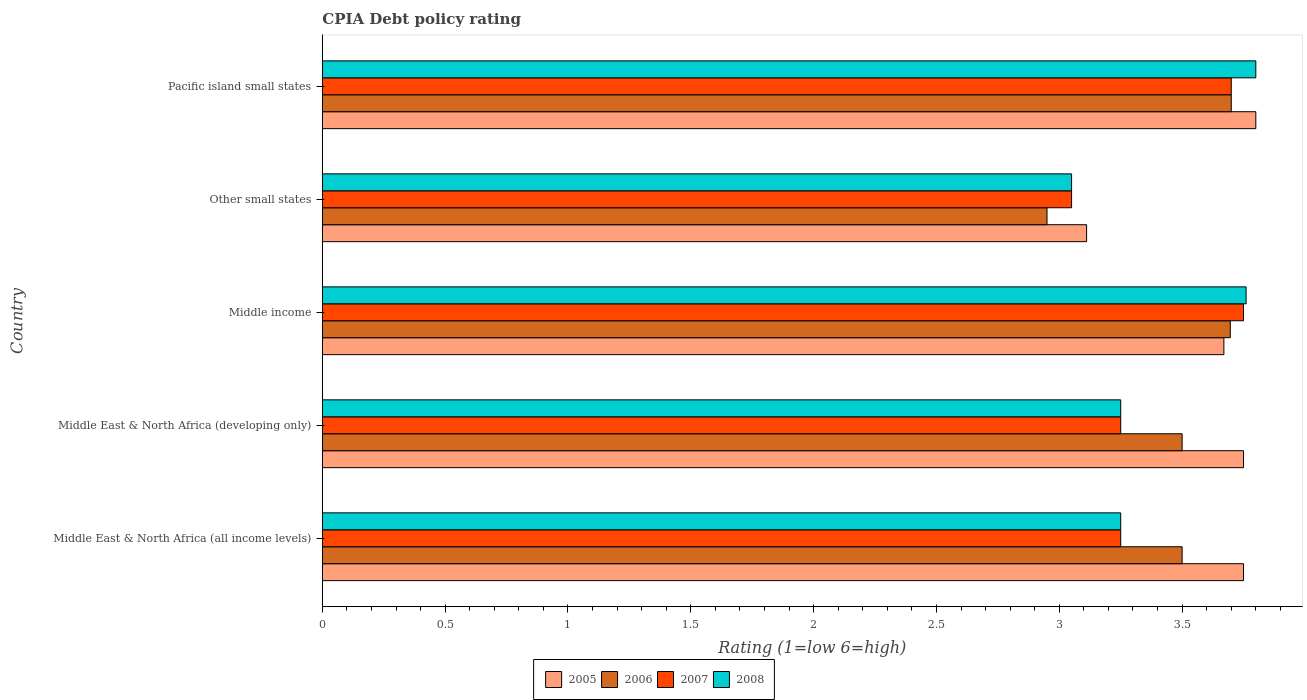How many different coloured bars are there?
Your answer should be very brief. 4. How many groups of bars are there?
Keep it short and to the point. 5. Are the number of bars on each tick of the Y-axis equal?
Offer a terse response. Yes. How many bars are there on the 5th tick from the bottom?
Your answer should be very brief. 4. What is the label of the 1st group of bars from the top?
Your response must be concise. Pacific island small states. Across all countries, what is the minimum CPIA rating in 2006?
Give a very brief answer. 2.95. In which country was the CPIA rating in 2008 maximum?
Offer a terse response. Pacific island small states. In which country was the CPIA rating in 2007 minimum?
Your answer should be compact. Other small states. What is the total CPIA rating in 2008 in the graph?
Give a very brief answer. 17.11. What is the difference between the CPIA rating in 2006 in Middle East & North Africa (all income levels) and that in Middle income?
Make the answer very short. -0.2. What is the difference between the CPIA rating in 2008 in Other small states and the CPIA rating in 2007 in Middle East & North Africa (developing only)?
Ensure brevity in your answer.  -0.2. What is the average CPIA rating in 2005 per country?
Keep it short and to the point. 3.62. What is the difference between the CPIA rating in 2008 and CPIA rating in 2006 in Middle income?
Offer a very short reply. 0.06. What is the ratio of the CPIA rating in 2008 in Middle East & North Africa (developing only) to that in Pacific island small states?
Your answer should be very brief. 0.86. What is the difference between the highest and the second highest CPIA rating in 2008?
Offer a terse response. 0.04. What is the difference between the highest and the lowest CPIA rating in 2005?
Your response must be concise. 0.69. In how many countries, is the CPIA rating in 2005 greater than the average CPIA rating in 2005 taken over all countries?
Make the answer very short. 4. Is it the case that in every country, the sum of the CPIA rating in 2006 and CPIA rating in 2008 is greater than the sum of CPIA rating in 2007 and CPIA rating in 2005?
Keep it short and to the point. No. Are all the bars in the graph horizontal?
Ensure brevity in your answer.  Yes. How are the legend labels stacked?
Make the answer very short. Horizontal. What is the title of the graph?
Provide a succinct answer. CPIA Debt policy rating. Does "2007" appear as one of the legend labels in the graph?
Ensure brevity in your answer.  Yes. What is the label or title of the X-axis?
Offer a very short reply. Rating (1=low 6=high). What is the Rating (1=low 6=high) of 2005 in Middle East & North Africa (all income levels)?
Your response must be concise. 3.75. What is the Rating (1=low 6=high) of 2005 in Middle East & North Africa (developing only)?
Ensure brevity in your answer.  3.75. What is the Rating (1=low 6=high) of 2006 in Middle East & North Africa (developing only)?
Give a very brief answer. 3.5. What is the Rating (1=low 6=high) in 2005 in Middle income?
Ensure brevity in your answer.  3.67. What is the Rating (1=low 6=high) of 2006 in Middle income?
Ensure brevity in your answer.  3.7. What is the Rating (1=low 6=high) of 2007 in Middle income?
Ensure brevity in your answer.  3.75. What is the Rating (1=low 6=high) in 2008 in Middle income?
Offer a very short reply. 3.76. What is the Rating (1=low 6=high) in 2005 in Other small states?
Give a very brief answer. 3.11. What is the Rating (1=low 6=high) in 2006 in Other small states?
Offer a terse response. 2.95. What is the Rating (1=low 6=high) of 2007 in Other small states?
Offer a terse response. 3.05. What is the Rating (1=low 6=high) of 2008 in Other small states?
Your response must be concise. 3.05. What is the Rating (1=low 6=high) of 2007 in Pacific island small states?
Your answer should be very brief. 3.7. Across all countries, what is the maximum Rating (1=low 6=high) in 2006?
Keep it short and to the point. 3.7. Across all countries, what is the maximum Rating (1=low 6=high) in 2007?
Give a very brief answer. 3.75. Across all countries, what is the maximum Rating (1=low 6=high) in 2008?
Offer a terse response. 3.8. Across all countries, what is the minimum Rating (1=low 6=high) in 2005?
Make the answer very short. 3.11. Across all countries, what is the minimum Rating (1=low 6=high) of 2006?
Provide a succinct answer. 2.95. Across all countries, what is the minimum Rating (1=low 6=high) of 2007?
Provide a succinct answer. 3.05. Across all countries, what is the minimum Rating (1=low 6=high) in 2008?
Offer a terse response. 3.05. What is the total Rating (1=low 6=high) in 2005 in the graph?
Your answer should be very brief. 18.08. What is the total Rating (1=low 6=high) of 2006 in the graph?
Your answer should be very brief. 17.35. What is the total Rating (1=low 6=high) of 2007 in the graph?
Offer a very short reply. 17. What is the total Rating (1=low 6=high) in 2008 in the graph?
Ensure brevity in your answer.  17.11. What is the difference between the Rating (1=low 6=high) of 2006 in Middle East & North Africa (all income levels) and that in Middle East & North Africa (developing only)?
Offer a terse response. 0. What is the difference between the Rating (1=low 6=high) of 2006 in Middle East & North Africa (all income levels) and that in Middle income?
Your answer should be compact. -0.2. What is the difference between the Rating (1=low 6=high) in 2008 in Middle East & North Africa (all income levels) and that in Middle income?
Your response must be concise. -0.51. What is the difference between the Rating (1=low 6=high) of 2005 in Middle East & North Africa (all income levels) and that in Other small states?
Offer a very short reply. 0.64. What is the difference between the Rating (1=low 6=high) in 2006 in Middle East & North Africa (all income levels) and that in Other small states?
Provide a succinct answer. 0.55. What is the difference between the Rating (1=low 6=high) in 2007 in Middle East & North Africa (all income levels) and that in Other small states?
Offer a very short reply. 0.2. What is the difference between the Rating (1=low 6=high) of 2008 in Middle East & North Africa (all income levels) and that in Other small states?
Your response must be concise. 0.2. What is the difference between the Rating (1=low 6=high) in 2007 in Middle East & North Africa (all income levels) and that in Pacific island small states?
Give a very brief answer. -0.45. What is the difference between the Rating (1=low 6=high) in 2008 in Middle East & North Africa (all income levels) and that in Pacific island small states?
Your answer should be compact. -0.55. What is the difference between the Rating (1=low 6=high) in 2006 in Middle East & North Africa (developing only) and that in Middle income?
Your answer should be compact. -0.2. What is the difference between the Rating (1=low 6=high) of 2008 in Middle East & North Africa (developing only) and that in Middle income?
Provide a succinct answer. -0.51. What is the difference between the Rating (1=low 6=high) of 2005 in Middle East & North Africa (developing only) and that in Other small states?
Ensure brevity in your answer.  0.64. What is the difference between the Rating (1=low 6=high) in 2006 in Middle East & North Africa (developing only) and that in Other small states?
Your answer should be very brief. 0.55. What is the difference between the Rating (1=low 6=high) of 2007 in Middle East & North Africa (developing only) and that in Other small states?
Provide a short and direct response. 0.2. What is the difference between the Rating (1=low 6=high) in 2008 in Middle East & North Africa (developing only) and that in Other small states?
Give a very brief answer. 0.2. What is the difference between the Rating (1=low 6=high) of 2005 in Middle East & North Africa (developing only) and that in Pacific island small states?
Offer a very short reply. -0.05. What is the difference between the Rating (1=low 6=high) of 2006 in Middle East & North Africa (developing only) and that in Pacific island small states?
Provide a short and direct response. -0.2. What is the difference between the Rating (1=low 6=high) in 2007 in Middle East & North Africa (developing only) and that in Pacific island small states?
Your answer should be very brief. -0.45. What is the difference between the Rating (1=low 6=high) in 2008 in Middle East & North Africa (developing only) and that in Pacific island small states?
Your answer should be very brief. -0.55. What is the difference between the Rating (1=low 6=high) in 2005 in Middle income and that in Other small states?
Give a very brief answer. 0.56. What is the difference between the Rating (1=low 6=high) in 2006 in Middle income and that in Other small states?
Your answer should be very brief. 0.75. What is the difference between the Rating (1=low 6=high) of 2007 in Middle income and that in Other small states?
Provide a short and direct response. 0.7. What is the difference between the Rating (1=low 6=high) of 2008 in Middle income and that in Other small states?
Make the answer very short. 0.71. What is the difference between the Rating (1=low 6=high) of 2005 in Middle income and that in Pacific island small states?
Make the answer very short. -0.13. What is the difference between the Rating (1=low 6=high) in 2006 in Middle income and that in Pacific island small states?
Provide a succinct answer. -0. What is the difference between the Rating (1=low 6=high) of 2008 in Middle income and that in Pacific island small states?
Make the answer very short. -0.04. What is the difference between the Rating (1=low 6=high) of 2005 in Other small states and that in Pacific island small states?
Your response must be concise. -0.69. What is the difference between the Rating (1=low 6=high) in 2006 in Other small states and that in Pacific island small states?
Keep it short and to the point. -0.75. What is the difference between the Rating (1=low 6=high) in 2007 in Other small states and that in Pacific island small states?
Your answer should be compact. -0.65. What is the difference between the Rating (1=low 6=high) in 2008 in Other small states and that in Pacific island small states?
Make the answer very short. -0.75. What is the difference between the Rating (1=low 6=high) in 2005 in Middle East & North Africa (all income levels) and the Rating (1=low 6=high) in 2006 in Middle East & North Africa (developing only)?
Your answer should be compact. 0.25. What is the difference between the Rating (1=low 6=high) of 2005 in Middle East & North Africa (all income levels) and the Rating (1=low 6=high) of 2007 in Middle East & North Africa (developing only)?
Your response must be concise. 0.5. What is the difference between the Rating (1=low 6=high) in 2005 in Middle East & North Africa (all income levels) and the Rating (1=low 6=high) in 2008 in Middle East & North Africa (developing only)?
Offer a terse response. 0.5. What is the difference between the Rating (1=low 6=high) of 2006 in Middle East & North Africa (all income levels) and the Rating (1=low 6=high) of 2008 in Middle East & North Africa (developing only)?
Ensure brevity in your answer.  0.25. What is the difference between the Rating (1=low 6=high) of 2007 in Middle East & North Africa (all income levels) and the Rating (1=low 6=high) of 2008 in Middle East & North Africa (developing only)?
Provide a short and direct response. 0. What is the difference between the Rating (1=low 6=high) of 2005 in Middle East & North Africa (all income levels) and the Rating (1=low 6=high) of 2006 in Middle income?
Keep it short and to the point. 0.05. What is the difference between the Rating (1=low 6=high) in 2005 in Middle East & North Africa (all income levels) and the Rating (1=low 6=high) in 2007 in Middle income?
Make the answer very short. 0. What is the difference between the Rating (1=low 6=high) of 2005 in Middle East & North Africa (all income levels) and the Rating (1=low 6=high) of 2008 in Middle income?
Offer a terse response. -0.01. What is the difference between the Rating (1=low 6=high) in 2006 in Middle East & North Africa (all income levels) and the Rating (1=low 6=high) in 2008 in Middle income?
Ensure brevity in your answer.  -0.26. What is the difference between the Rating (1=low 6=high) in 2007 in Middle East & North Africa (all income levels) and the Rating (1=low 6=high) in 2008 in Middle income?
Offer a terse response. -0.51. What is the difference between the Rating (1=low 6=high) of 2006 in Middle East & North Africa (all income levels) and the Rating (1=low 6=high) of 2007 in Other small states?
Your answer should be very brief. 0.45. What is the difference between the Rating (1=low 6=high) of 2006 in Middle East & North Africa (all income levels) and the Rating (1=low 6=high) of 2008 in Other small states?
Ensure brevity in your answer.  0.45. What is the difference between the Rating (1=low 6=high) of 2005 in Middle East & North Africa (all income levels) and the Rating (1=low 6=high) of 2008 in Pacific island small states?
Make the answer very short. -0.05. What is the difference between the Rating (1=low 6=high) in 2006 in Middle East & North Africa (all income levels) and the Rating (1=low 6=high) in 2008 in Pacific island small states?
Your response must be concise. -0.3. What is the difference between the Rating (1=low 6=high) in 2007 in Middle East & North Africa (all income levels) and the Rating (1=low 6=high) in 2008 in Pacific island small states?
Provide a short and direct response. -0.55. What is the difference between the Rating (1=low 6=high) of 2005 in Middle East & North Africa (developing only) and the Rating (1=low 6=high) of 2006 in Middle income?
Ensure brevity in your answer.  0.05. What is the difference between the Rating (1=low 6=high) in 2005 in Middle East & North Africa (developing only) and the Rating (1=low 6=high) in 2007 in Middle income?
Offer a very short reply. 0. What is the difference between the Rating (1=low 6=high) of 2005 in Middle East & North Africa (developing only) and the Rating (1=low 6=high) of 2008 in Middle income?
Your answer should be very brief. -0.01. What is the difference between the Rating (1=low 6=high) in 2006 in Middle East & North Africa (developing only) and the Rating (1=low 6=high) in 2007 in Middle income?
Your answer should be very brief. -0.25. What is the difference between the Rating (1=low 6=high) in 2006 in Middle East & North Africa (developing only) and the Rating (1=low 6=high) in 2008 in Middle income?
Your response must be concise. -0.26. What is the difference between the Rating (1=low 6=high) in 2007 in Middle East & North Africa (developing only) and the Rating (1=low 6=high) in 2008 in Middle income?
Your answer should be very brief. -0.51. What is the difference between the Rating (1=low 6=high) of 2005 in Middle East & North Africa (developing only) and the Rating (1=low 6=high) of 2006 in Other small states?
Offer a terse response. 0.8. What is the difference between the Rating (1=low 6=high) in 2005 in Middle East & North Africa (developing only) and the Rating (1=low 6=high) in 2008 in Other small states?
Provide a succinct answer. 0.7. What is the difference between the Rating (1=low 6=high) of 2006 in Middle East & North Africa (developing only) and the Rating (1=low 6=high) of 2007 in Other small states?
Give a very brief answer. 0.45. What is the difference between the Rating (1=low 6=high) in 2006 in Middle East & North Africa (developing only) and the Rating (1=low 6=high) in 2008 in Other small states?
Give a very brief answer. 0.45. What is the difference between the Rating (1=low 6=high) of 2007 in Middle East & North Africa (developing only) and the Rating (1=low 6=high) of 2008 in Other small states?
Your answer should be very brief. 0.2. What is the difference between the Rating (1=low 6=high) of 2007 in Middle East & North Africa (developing only) and the Rating (1=low 6=high) of 2008 in Pacific island small states?
Make the answer very short. -0.55. What is the difference between the Rating (1=low 6=high) of 2005 in Middle income and the Rating (1=low 6=high) of 2006 in Other small states?
Ensure brevity in your answer.  0.72. What is the difference between the Rating (1=low 6=high) in 2005 in Middle income and the Rating (1=low 6=high) in 2007 in Other small states?
Make the answer very short. 0.62. What is the difference between the Rating (1=low 6=high) of 2005 in Middle income and the Rating (1=low 6=high) of 2008 in Other small states?
Offer a terse response. 0.62. What is the difference between the Rating (1=low 6=high) of 2006 in Middle income and the Rating (1=low 6=high) of 2007 in Other small states?
Offer a terse response. 0.65. What is the difference between the Rating (1=low 6=high) in 2006 in Middle income and the Rating (1=low 6=high) in 2008 in Other small states?
Your answer should be very brief. 0.65. What is the difference between the Rating (1=low 6=high) of 2007 in Middle income and the Rating (1=low 6=high) of 2008 in Other small states?
Provide a short and direct response. 0.7. What is the difference between the Rating (1=low 6=high) of 2005 in Middle income and the Rating (1=low 6=high) of 2006 in Pacific island small states?
Your answer should be compact. -0.03. What is the difference between the Rating (1=low 6=high) of 2005 in Middle income and the Rating (1=low 6=high) of 2007 in Pacific island small states?
Provide a succinct answer. -0.03. What is the difference between the Rating (1=low 6=high) in 2005 in Middle income and the Rating (1=low 6=high) in 2008 in Pacific island small states?
Give a very brief answer. -0.13. What is the difference between the Rating (1=low 6=high) of 2006 in Middle income and the Rating (1=low 6=high) of 2007 in Pacific island small states?
Ensure brevity in your answer.  -0. What is the difference between the Rating (1=low 6=high) in 2006 in Middle income and the Rating (1=low 6=high) in 2008 in Pacific island small states?
Give a very brief answer. -0.1. What is the difference between the Rating (1=low 6=high) in 2005 in Other small states and the Rating (1=low 6=high) in 2006 in Pacific island small states?
Offer a terse response. -0.59. What is the difference between the Rating (1=low 6=high) in 2005 in Other small states and the Rating (1=low 6=high) in 2007 in Pacific island small states?
Your answer should be compact. -0.59. What is the difference between the Rating (1=low 6=high) of 2005 in Other small states and the Rating (1=low 6=high) of 2008 in Pacific island small states?
Provide a succinct answer. -0.69. What is the difference between the Rating (1=low 6=high) of 2006 in Other small states and the Rating (1=low 6=high) of 2007 in Pacific island small states?
Give a very brief answer. -0.75. What is the difference between the Rating (1=low 6=high) of 2006 in Other small states and the Rating (1=low 6=high) of 2008 in Pacific island small states?
Keep it short and to the point. -0.85. What is the difference between the Rating (1=low 6=high) of 2007 in Other small states and the Rating (1=low 6=high) of 2008 in Pacific island small states?
Offer a very short reply. -0.75. What is the average Rating (1=low 6=high) in 2005 per country?
Offer a very short reply. 3.62. What is the average Rating (1=low 6=high) in 2006 per country?
Ensure brevity in your answer.  3.47. What is the average Rating (1=low 6=high) of 2008 per country?
Offer a very short reply. 3.42. What is the difference between the Rating (1=low 6=high) of 2005 and Rating (1=low 6=high) of 2007 in Middle East & North Africa (all income levels)?
Your response must be concise. 0.5. What is the difference between the Rating (1=low 6=high) in 2005 and Rating (1=low 6=high) in 2008 in Middle East & North Africa (all income levels)?
Give a very brief answer. 0.5. What is the difference between the Rating (1=low 6=high) in 2006 and Rating (1=low 6=high) in 2007 in Middle East & North Africa (all income levels)?
Give a very brief answer. 0.25. What is the difference between the Rating (1=low 6=high) of 2006 and Rating (1=low 6=high) of 2008 in Middle East & North Africa (all income levels)?
Offer a terse response. 0.25. What is the difference between the Rating (1=low 6=high) of 2007 and Rating (1=low 6=high) of 2008 in Middle East & North Africa (all income levels)?
Give a very brief answer. 0. What is the difference between the Rating (1=low 6=high) of 2005 and Rating (1=low 6=high) of 2006 in Middle East & North Africa (developing only)?
Your answer should be very brief. 0.25. What is the difference between the Rating (1=low 6=high) in 2005 and Rating (1=low 6=high) in 2007 in Middle East & North Africa (developing only)?
Your response must be concise. 0.5. What is the difference between the Rating (1=low 6=high) in 2005 and Rating (1=low 6=high) in 2008 in Middle East & North Africa (developing only)?
Offer a terse response. 0.5. What is the difference between the Rating (1=low 6=high) in 2006 and Rating (1=low 6=high) in 2008 in Middle East & North Africa (developing only)?
Offer a very short reply. 0.25. What is the difference between the Rating (1=low 6=high) in 2005 and Rating (1=low 6=high) in 2006 in Middle income?
Ensure brevity in your answer.  -0.03. What is the difference between the Rating (1=low 6=high) of 2005 and Rating (1=low 6=high) of 2007 in Middle income?
Ensure brevity in your answer.  -0.08. What is the difference between the Rating (1=low 6=high) in 2005 and Rating (1=low 6=high) in 2008 in Middle income?
Provide a succinct answer. -0.09. What is the difference between the Rating (1=low 6=high) in 2006 and Rating (1=low 6=high) in 2007 in Middle income?
Provide a succinct answer. -0.05. What is the difference between the Rating (1=low 6=high) in 2006 and Rating (1=low 6=high) in 2008 in Middle income?
Your answer should be very brief. -0.06. What is the difference between the Rating (1=low 6=high) in 2007 and Rating (1=low 6=high) in 2008 in Middle income?
Keep it short and to the point. -0.01. What is the difference between the Rating (1=low 6=high) in 2005 and Rating (1=low 6=high) in 2006 in Other small states?
Offer a very short reply. 0.16. What is the difference between the Rating (1=low 6=high) of 2005 and Rating (1=low 6=high) of 2007 in Other small states?
Make the answer very short. 0.06. What is the difference between the Rating (1=low 6=high) in 2005 and Rating (1=low 6=high) in 2008 in Other small states?
Offer a terse response. 0.06. What is the difference between the Rating (1=low 6=high) of 2006 and Rating (1=low 6=high) of 2007 in Other small states?
Your response must be concise. -0.1. What is the difference between the Rating (1=low 6=high) in 2006 and Rating (1=low 6=high) in 2008 in Other small states?
Provide a succinct answer. -0.1. What is the difference between the Rating (1=low 6=high) of 2007 and Rating (1=low 6=high) of 2008 in Other small states?
Your answer should be compact. 0. What is the difference between the Rating (1=low 6=high) in 2005 and Rating (1=low 6=high) in 2006 in Pacific island small states?
Make the answer very short. 0.1. What is the difference between the Rating (1=low 6=high) of 2006 and Rating (1=low 6=high) of 2007 in Pacific island small states?
Give a very brief answer. 0. What is the difference between the Rating (1=low 6=high) in 2006 and Rating (1=low 6=high) in 2008 in Pacific island small states?
Offer a very short reply. -0.1. What is the difference between the Rating (1=low 6=high) of 2007 and Rating (1=low 6=high) of 2008 in Pacific island small states?
Provide a short and direct response. -0.1. What is the ratio of the Rating (1=low 6=high) in 2007 in Middle East & North Africa (all income levels) to that in Middle East & North Africa (developing only)?
Make the answer very short. 1. What is the ratio of the Rating (1=low 6=high) in 2008 in Middle East & North Africa (all income levels) to that in Middle East & North Africa (developing only)?
Your response must be concise. 1. What is the ratio of the Rating (1=low 6=high) in 2005 in Middle East & North Africa (all income levels) to that in Middle income?
Offer a terse response. 1.02. What is the ratio of the Rating (1=low 6=high) of 2006 in Middle East & North Africa (all income levels) to that in Middle income?
Keep it short and to the point. 0.95. What is the ratio of the Rating (1=low 6=high) of 2007 in Middle East & North Africa (all income levels) to that in Middle income?
Your answer should be compact. 0.87. What is the ratio of the Rating (1=low 6=high) in 2008 in Middle East & North Africa (all income levels) to that in Middle income?
Provide a short and direct response. 0.86. What is the ratio of the Rating (1=low 6=high) in 2005 in Middle East & North Africa (all income levels) to that in Other small states?
Give a very brief answer. 1.21. What is the ratio of the Rating (1=low 6=high) in 2006 in Middle East & North Africa (all income levels) to that in Other small states?
Your answer should be compact. 1.19. What is the ratio of the Rating (1=low 6=high) of 2007 in Middle East & North Africa (all income levels) to that in Other small states?
Ensure brevity in your answer.  1.07. What is the ratio of the Rating (1=low 6=high) of 2008 in Middle East & North Africa (all income levels) to that in Other small states?
Your answer should be compact. 1.07. What is the ratio of the Rating (1=low 6=high) in 2006 in Middle East & North Africa (all income levels) to that in Pacific island small states?
Keep it short and to the point. 0.95. What is the ratio of the Rating (1=low 6=high) in 2007 in Middle East & North Africa (all income levels) to that in Pacific island small states?
Your response must be concise. 0.88. What is the ratio of the Rating (1=low 6=high) in 2008 in Middle East & North Africa (all income levels) to that in Pacific island small states?
Make the answer very short. 0.86. What is the ratio of the Rating (1=low 6=high) of 2005 in Middle East & North Africa (developing only) to that in Middle income?
Provide a succinct answer. 1.02. What is the ratio of the Rating (1=low 6=high) in 2006 in Middle East & North Africa (developing only) to that in Middle income?
Your response must be concise. 0.95. What is the ratio of the Rating (1=low 6=high) in 2007 in Middle East & North Africa (developing only) to that in Middle income?
Provide a short and direct response. 0.87. What is the ratio of the Rating (1=low 6=high) of 2008 in Middle East & North Africa (developing only) to that in Middle income?
Provide a succinct answer. 0.86. What is the ratio of the Rating (1=low 6=high) of 2005 in Middle East & North Africa (developing only) to that in Other small states?
Your answer should be compact. 1.21. What is the ratio of the Rating (1=low 6=high) of 2006 in Middle East & North Africa (developing only) to that in Other small states?
Keep it short and to the point. 1.19. What is the ratio of the Rating (1=low 6=high) in 2007 in Middle East & North Africa (developing only) to that in Other small states?
Offer a very short reply. 1.07. What is the ratio of the Rating (1=low 6=high) of 2008 in Middle East & North Africa (developing only) to that in Other small states?
Keep it short and to the point. 1.07. What is the ratio of the Rating (1=low 6=high) in 2006 in Middle East & North Africa (developing only) to that in Pacific island small states?
Your answer should be very brief. 0.95. What is the ratio of the Rating (1=low 6=high) of 2007 in Middle East & North Africa (developing only) to that in Pacific island small states?
Your response must be concise. 0.88. What is the ratio of the Rating (1=low 6=high) in 2008 in Middle East & North Africa (developing only) to that in Pacific island small states?
Offer a terse response. 0.86. What is the ratio of the Rating (1=low 6=high) in 2005 in Middle income to that in Other small states?
Make the answer very short. 1.18. What is the ratio of the Rating (1=low 6=high) of 2006 in Middle income to that in Other small states?
Offer a terse response. 1.25. What is the ratio of the Rating (1=low 6=high) in 2007 in Middle income to that in Other small states?
Your response must be concise. 1.23. What is the ratio of the Rating (1=low 6=high) of 2008 in Middle income to that in Other small states?
Offer a terse response. 1.23. What is the ratio of the Rating (1=low 6=high) in 2005 in Middle income to that in Pacific island small states?
Make the answer very short. 0.97. What is the ratio of the Rating (1=low 6=high) of 2006 in Middle income to that in Pacific island small states?
Give a very brief answer. 1. What is the ratio of the Rating (1=low 6=high) of 2007 in Middle income to that in Pacific island small states?
Provide a succinct answer. 1.01. What is the ratio of the Rating (1=low 6=high) of 2005 in Other small states to that in Pacific island small states?
Keep it short and to the point. 0.82. What is the ratio of the Rating (1=low 6=high) of 2006 in Other small states to that in Pacific island small states?
Your answer should be very brief. 0.8. What is the ratio of the Rating (1=low 6=high) in 2007 in Other small states to that in Pacific island small states?
Your response must be concise. 0.82. What is the ratio of the Rating (1=low 6=high) in 2008 in Other small states to that in Pacific island small states?
Your answer should be compact. 0.8. What is the difference between the highest and the second highest Rating (1=low 6=high) of 2005?
Give a very brief answer. 0.05. What is the difference between the highest and the second highest Rating (1=low 6=high) of 2006?
Your answer should be compact. 0. What is the difference between the highest and the second highest Rating (1=low 6=high) in 2007?
Provide a short and direct response. 0.05. What is the difference between the highest and the second highest Rating (1=low 6=high) in 2008?
Give a very brief answer. 0.04. What is the difference between the highest and the lowest Rating (1=low 6=high) in 2005?
Provide a short and direct response. 0.69. What is the difference between the highest and the lowest Rating (1=low 6=high) of 2006?
Provide a succinct answer. 0.75. What is the difference between the highest and the lowest Rating (1=low 6=high) in 2007?
Offer a very short reply. 0.7. What is the difference between the highest and the lowest Rating (1=low 6=high) of 2008?
Give a very brief answer. 0.75. 